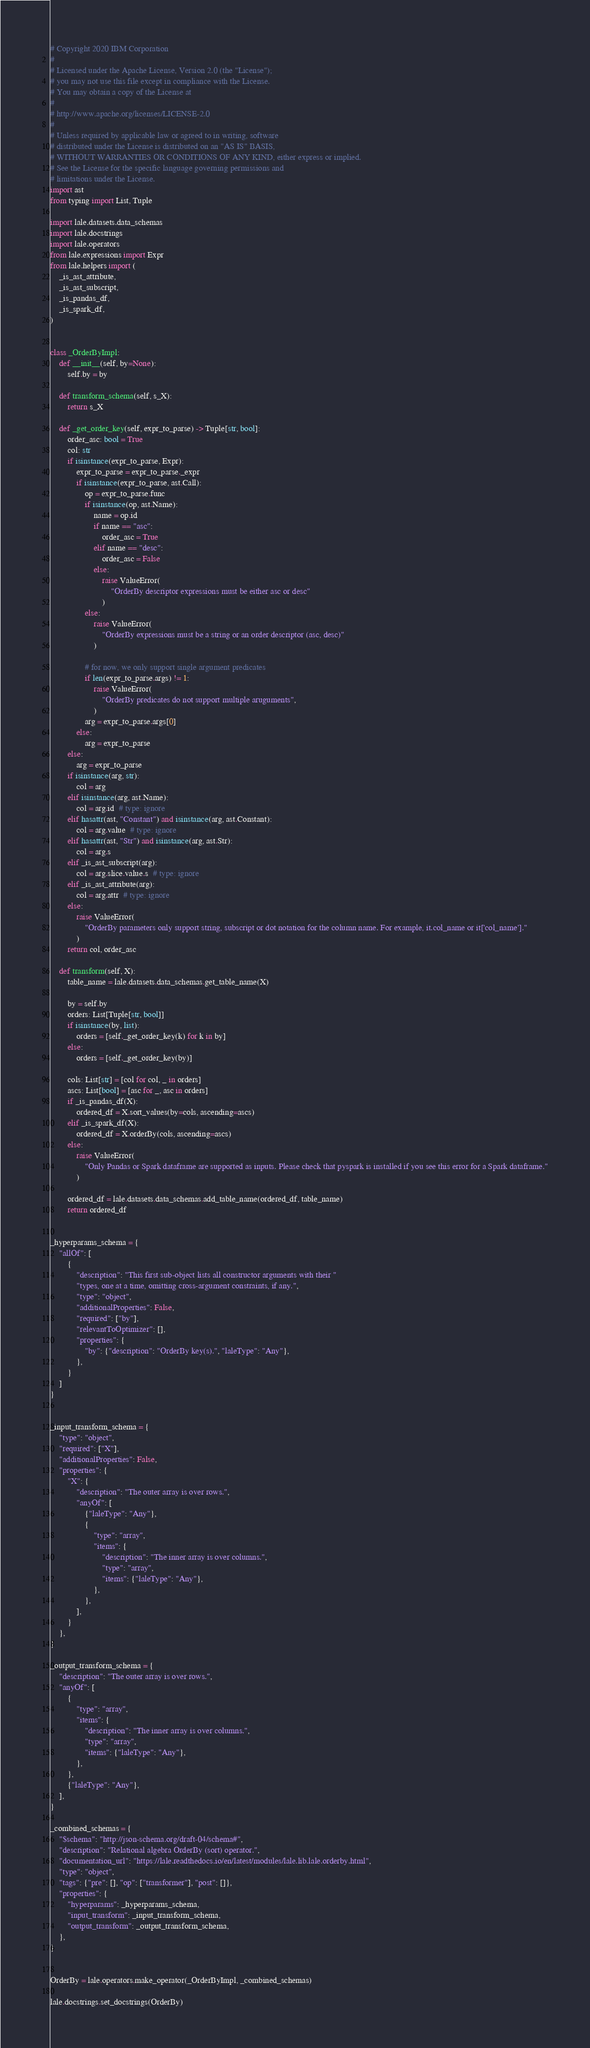Convert code to text. <code><loc_0><loc_0><loc_500><loc_500><_Python_># Copyright 2020 IBM Corporation
#
# Licensed under the Apache License, Version 2.0 (the "License");
# you may not use this file except in compliance with the License.
# You may obtain a copy of the License at
#
# http://www.apache.org/licenses/LICENSE-2.0
#
# Unless required by applicable law or agreed to in writing, software
# distributed under the License is distributed on an "AS IS" BASIS,
# WITHOUT WARRANTIES OR CONDITIONS OF ANY KIND, either express or implied.
# See the License for the specific language governing permissions and
# limitations under the License.
import ast
from typing import List, Tuple

import lale.datasets.data_schemas
import lale.docstrings
import lale.operators
from lale.expressions import Expr
from lale.helpers import (
    _is_ast_attribute,
    _is_ast_subscript,
    _is_pandas_df,
    _is_spark_df,
)


class _OrderByImpl:
    def __init__(self, by=None):
        self.by = by

    def transform_schema(self, s_X):
        return s_X

    def _get_order_key(self, expr_to_parse) -> Tuple[str, bool]:
        order_asc: bool = True
        col: str
        if isinstance(expr_to_parse, Expr):
            expr_to_parse = expr_to_parse._expr
            if isinstance(expr_to_parse, ast.Call):
                op = expr_to_parse.func
                if isinstance(op, ast.Name):
                    name = op.id
                    if name == "asc":
                        order_asc = True
                    elif name == "desc":
                        order_asc = False
                    else:
                        raise ValueError(
                            "OrderBy descriptor expressions must be either asc or desc"
                        )
                else:
                    raise ValueError(
                        "OrderBy expressions must be a string or an order descriptor (asc, desc)"
                    )

                # for now, we only support single argument predicates
                if len(expr_to_parse.args) != 1:
                    raise ValueError(
                        "OrderBy predicates do not support multiple aruguments",
                    )
                arg = expr_to_parse.args[0]
            else:
                arg = expr_to_parse
        else:
            arg = expr_to_parse
        if isinstance(arg, str):
            col = arg
        elif isinstance(arg, ast.Name):
            col = arg.id  # type: ignore
        elif hasattr(ast, "Constant") and isinstance(arg, ast.Constant):
            col = arg.value  # type: ignore
        elif hasattr(ast, "Str") and isinstance(arg, ast.Str):
            col = arg.s
        elif _is_ast_subscript(arg):
            col = arg.slice.value.s  # type: ignore
        elif _is_ast_attribute(arg):
            col = arg.attr  # type: ignore
        else:
            raise ValueError(
                "OrderBy parameters only support string, subscript or dot notation for the column name. For example, it.col_name or it['col_name']."
            )
        return col, order_asc

    def transform(self, X):
        table_name = lale.datasets.data_schemas.get_table_name(X)

        by = self.by
        orders: List[Tuple[str, bool]]
        if isinstance(by, list):
            orders = [self._get_order_key(k) for k in by]
        else:
            orders = [self._get_order_key(by)]

        cols: List[str] = [col for col, _ in orders]
        ascs: List[bool] = [asc for _, asc in orders]
        if _is_pandas_df(X):
            ordered_df = X.sort_values(by=cols, ascending=ascs)
        elif _is_spark_df(X):
            ordered_df = X.orderBy(cols, ascending=ascs)
        else:
            raise ValueError(
                "Only Pandas or Spark dataframe are supported as inputs. Please check that pyspark is installed if you see this error for a Spark dataframe."
            )

        ordered_df = lale.datasets.data_schemas.add_table_name(ordered_df, table_name)
        return ordered_df


_hyperparams_schema = {
    "allOf": [
        {
            "description": "This first sub-object lists all constructor arguments with their "
            "types, one at a time, omitting cross-argument constraints, if any.",
            "type": "object",
            "additionalProperties": False,
            "required": ["by"],
            "relevantToOptimizer": [],
            "properties": {
                "by": {"description": "OrderBy key(s).", "laleType": "Any"},
            },
        }
    ]
}


_input_transform_schema = {
    "type": "object",
    "required": ["X"],
    "additionalProperties": False,
    "properties": {
        "X": {
            "description": "The outer array is over rows.",
            "anyOf": [
                {"laleType": "Any"},
                {
                    "type": "array",
                    "items": {
                        "description": "The inner array is over columns.",
                        "type": "array",
                        "items": {"laleType": "Any"},
                    },
                },
            ],
        }
    },
}

_output_transform_schema = {
    "description": "The outer array is over rows.",
    "anyOf": [
        {
            "type": "array",
            "items": {
                "description": "The inner array is over columns.",
                "type": "array",
                "items": {"laleType": "Any"},
            },
        },
        {"laleType": "Any"},
    ],
}

_combined_schemas = {
    "$schema": "http://json-schema.org/draft-04/schema#",
    "description": "Relational algebra OrderBy (sort) operator.",
    "documentation_url": "https://lale.readthedocs.io/en/latest/modules/lale.lib.lale.orderby.html",
    "type": "object",
    "tags": {"pre": [], "op": ["transformer"], "post": []},
    "properties": {
        "hyperparams": _hyperparams_schema,
        "input_transform": _input_transform_schema,
        "output_transform": _output_transform_schema,
    },
}


OrderBy = lale.operators.make_operator(_OrderByImpl, _combined_schemas)

lale.docstrings.set_docstrings(OrderBy)
</code> 